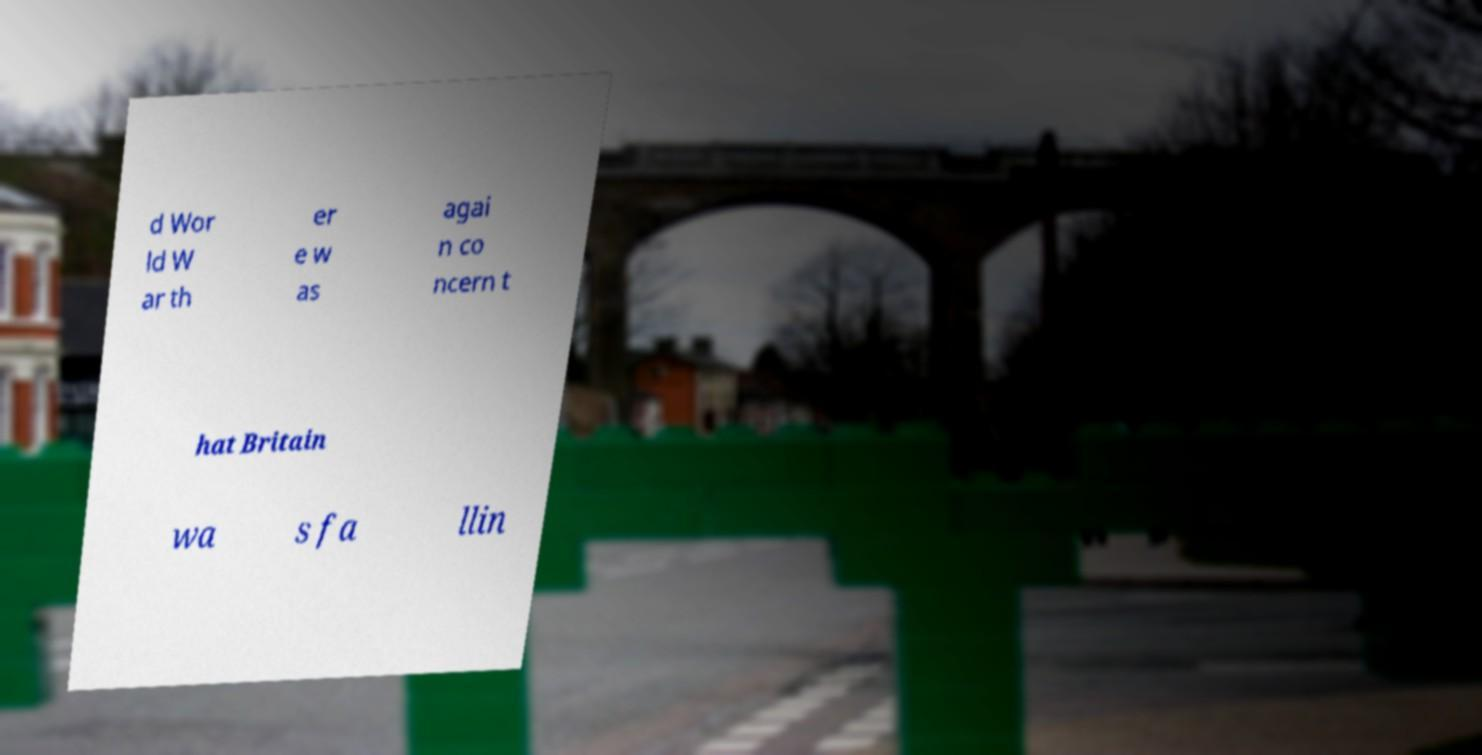Could you assist in decoding the text presented in this image and type it out clearly? d Wor ld W ar th er e w as agai n co ncern t hat Britain wa s fa llin 